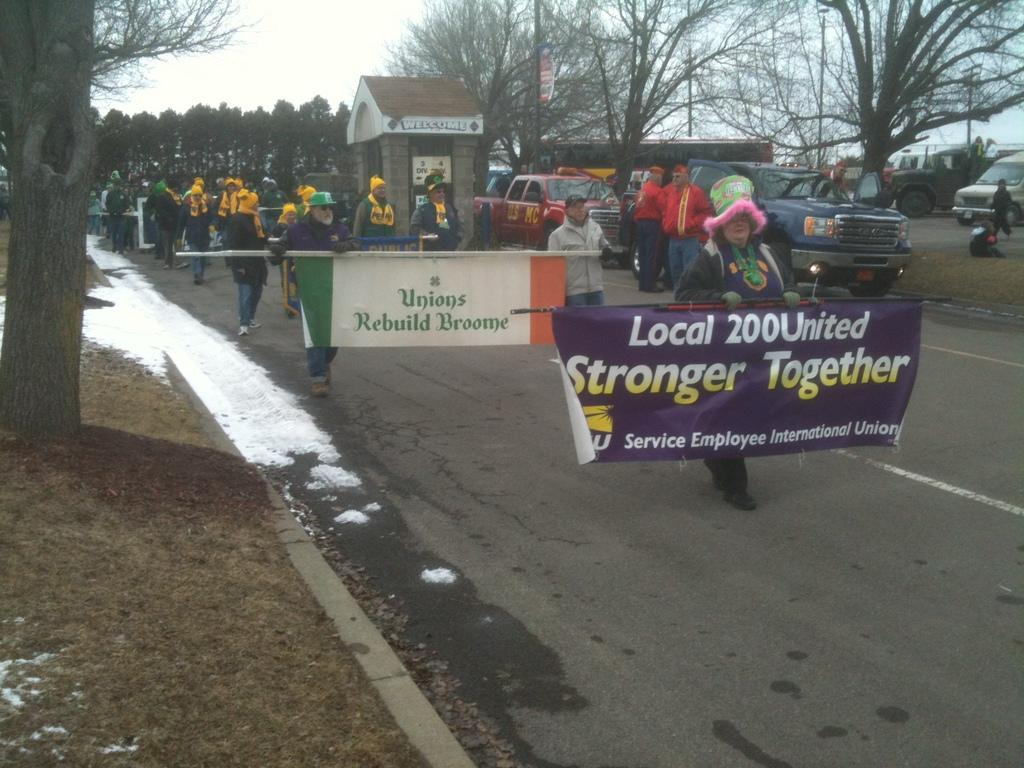<image>
Write a terse but informative summary of the picture. People are marching in support of labor unions, among them Local 200United. 